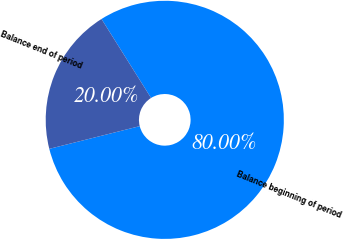Convert chart to OTSL. <chart><loc_0><loc_0><loc_500><loc_500><pie_chart><fcel>Balance beginning of period<fcel>Balance end of period<nl><fcel>80.0%<fcel>20.0%<nl></chart> 